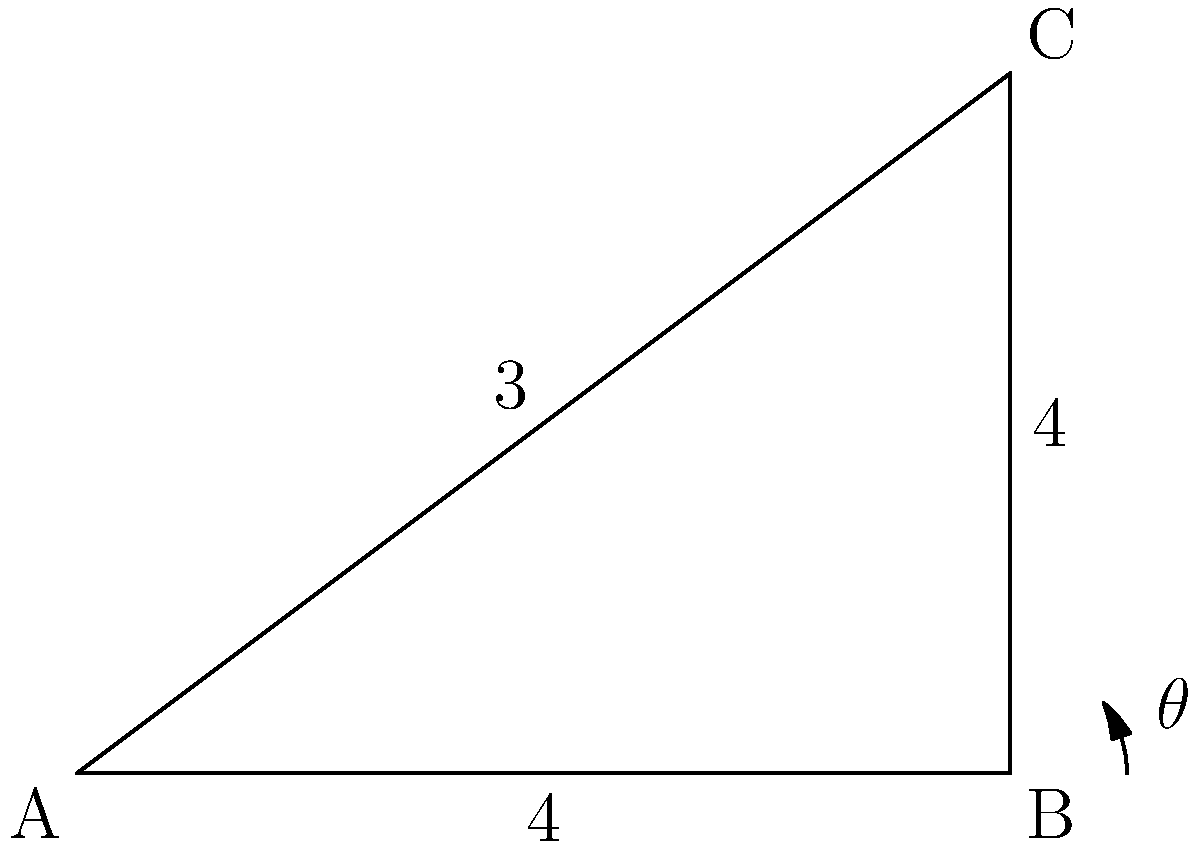In our wireless network security system, we need to position an antenna at a specific angle for optimal signal coverage. Given the diagram of the building layout, where the antenna needs to be placed at point B and reach point C, what is the angle $\theta$ (in degrees) required for proper antenna placement? To find the angle $\theta$, we need to use trigonometry:

1) We have a right triangle ABC, where:
   - The base (AB) is 4 units long
   - The height (BC) is 3 units long
   - The hypotenuse (AC) is the antenna's signal path

2) We can use the arctangent function to find the angle:
   $\theta = \arctan(\frac{\text{opposite}}{\text{adjacent}})$

3) In this case:
   $\theta = \arctan(\frac{BC}{AB}) = \arctan(\frac{3}{4})$

4) Calculate the result:
   $\theta = \arctan(0.75) \approx 36.87°$

5) Round to the nearest degree:
   $\theta \approx 37°$

This angle ensures that the antenna at point B is directed towards point C for optimal signal coverage in the wireless network security system.
Answer: 37° 